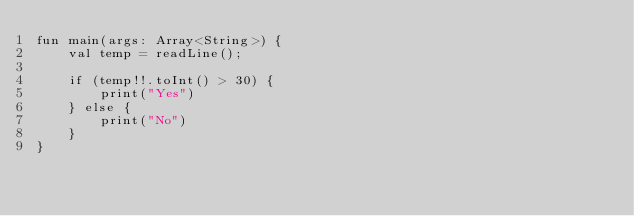<code> <loc_0><loc_0><loc_500><loc_500><_Kotlin_>fun main(args: Array<String>) {
    val temp = readLine();

    if (temp!!.toInt() > 30) {
        print("Yes")
    } else {
        print("No")
    }
}</code> 